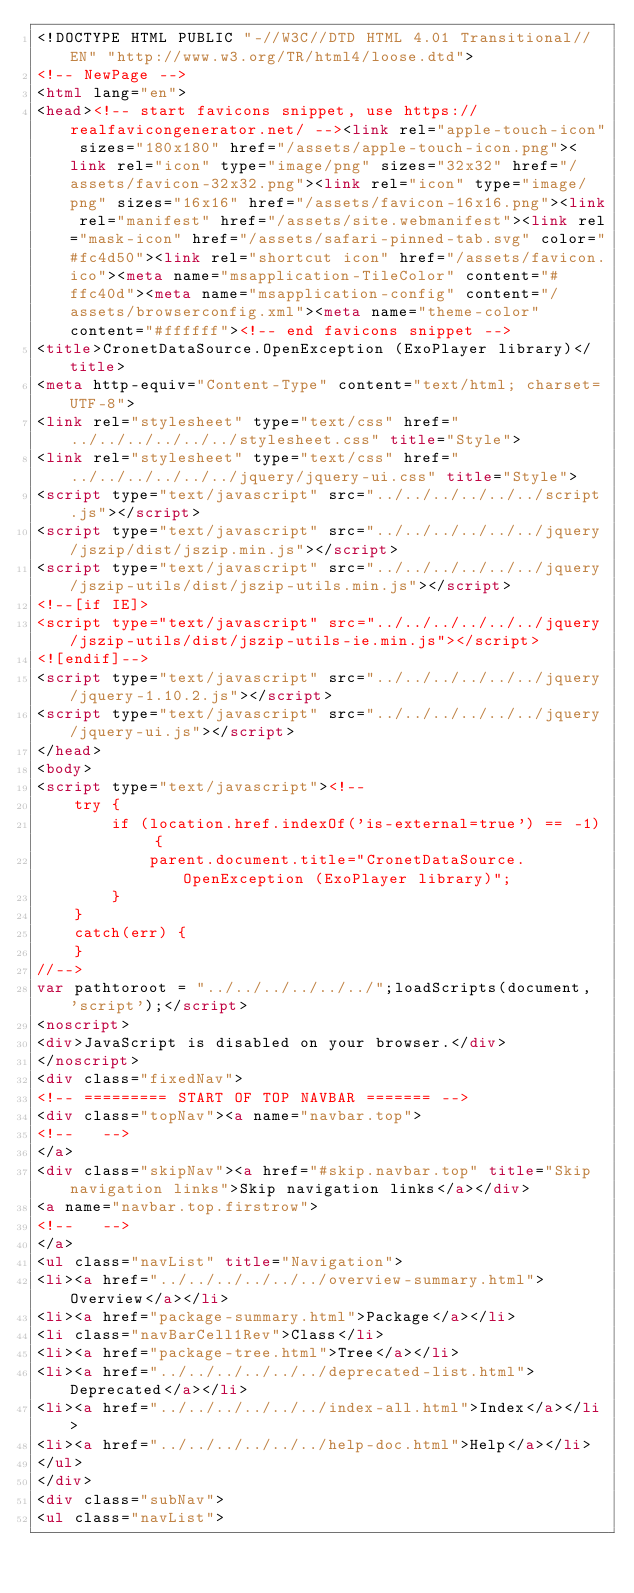<code> <loc_0><loc_0><loc_500><loc_500><_HTML_><!DOCTYPE HTML PUBLIC "-//W3C//DTD HTML 4.01 Transitional//EN" "http://www.w3.org/TR/html4/loose.dtd">
<!-- NewPage -->
<html lang="en">
<head><!-- start favicons snippet, use https://realfavicongenerator.net/ --><link rel="apple-touch-icon" sizes="180x180" href="/assets/apple-touch-icon.png"><link rel="icon" type="image/png" sizes="32x32" href="/assets/favicon-32x32.png"><link rel="icon" type="image/png" sizes="16x16" href="/assets/favicon-16x16.png"><link rel="manifest" href="/assets/site.webmanifest"><link rel="mask-icon" href="/assets/safari-pinned-tab.svg" color="#fc4d50"><link rel="shortcut icon" href="/assets/favicon.ico"><meta name="msapplication-TileColor" content="#ffc40d"><meta name="msapplication-config" content="/assets/browserconfig.xml"><meta name="theme-color" content="#ffffff"><!-- end favicons snippet -->
<title>CronetDataSource.OpenException (ExoPlayer library)</title>
<meta http-equiv="Content-Type" content="text/html; charset=UTF-8">
<link rel="stylesheet" type="text/css" href="../../../../../../stylesheet.css" title="Style">
<link rel="stylesheet" type="text/css" href="../../../../../../jquery/jquery-ui.css" title="Style">
<script type="text/javascript" src="../../../../../../script.js"></script>
<script type="text/javascript" src="../../../../../../jquery/jszip/dist/jszip.min.js"></script>
<script type="text/javascript" src="../../../../../../jquery/jszip-utils/dist/jszip-utils.min.js"></script>
<!--[if IE]>
<script type="text/javascript" src="../../../../../../jquery/jszip-utils/dist/jszip-utils-ie.min.js"></script>
<![endif]-->
<script type="text/javascript" src="../../../../../../jquery/jquery-1.10.2.js"></script>
<script type="text/javascript" src="../../../../../../jquery/jquery-ui.js"></script>
</head>
<body>
<script type="text/javascript"><!--
    try {
        if (location.href.indexOf('is-external=true') == -1) {
            parent.document.title="CronetDataSource.OpenException (ExoPlayer library)";
        }
    }
    catch(err) {
    }
//-->
var pathtoroot = "../../../../../../";loadScripts(document, 'script');</script>
<noscript>
<div>JavaScript is disabled on your browser.</div>
</noscript>
<div class="fixedNav">
<!-- ========= START OF TOP NAVBAR ======= -->
<div class="topNav"><a name="navbar.top">
<!--   -->
</a>
<div class="skipNav"><a href="#skip.navbar.top" title="Skip navigation links">Skip navigation links</a></div>
<a name="navbar.top.firstrow">
<!--   -->
</a>
<ul class="navList" title="Navigation">
<li><a href="../../../../../../overview-summary.html">Overview</a></li>
<li><a href="package-summary.html">Package</a></li>
<li class="navBarCell1Rev">Class</li>
<li><a href="package-tree.html">Tree</a></li>
<li><a href="../../../../../../deprecated-list.html">Deprecated</a></li>
<li><a href="../../../../../../index-all.html">Index</a></li>
<li><a href="../../../../../../help-doc.html">Help</a></li>
</ul>
</div>
<div class="subNav">
<ul class="navList"></code> 